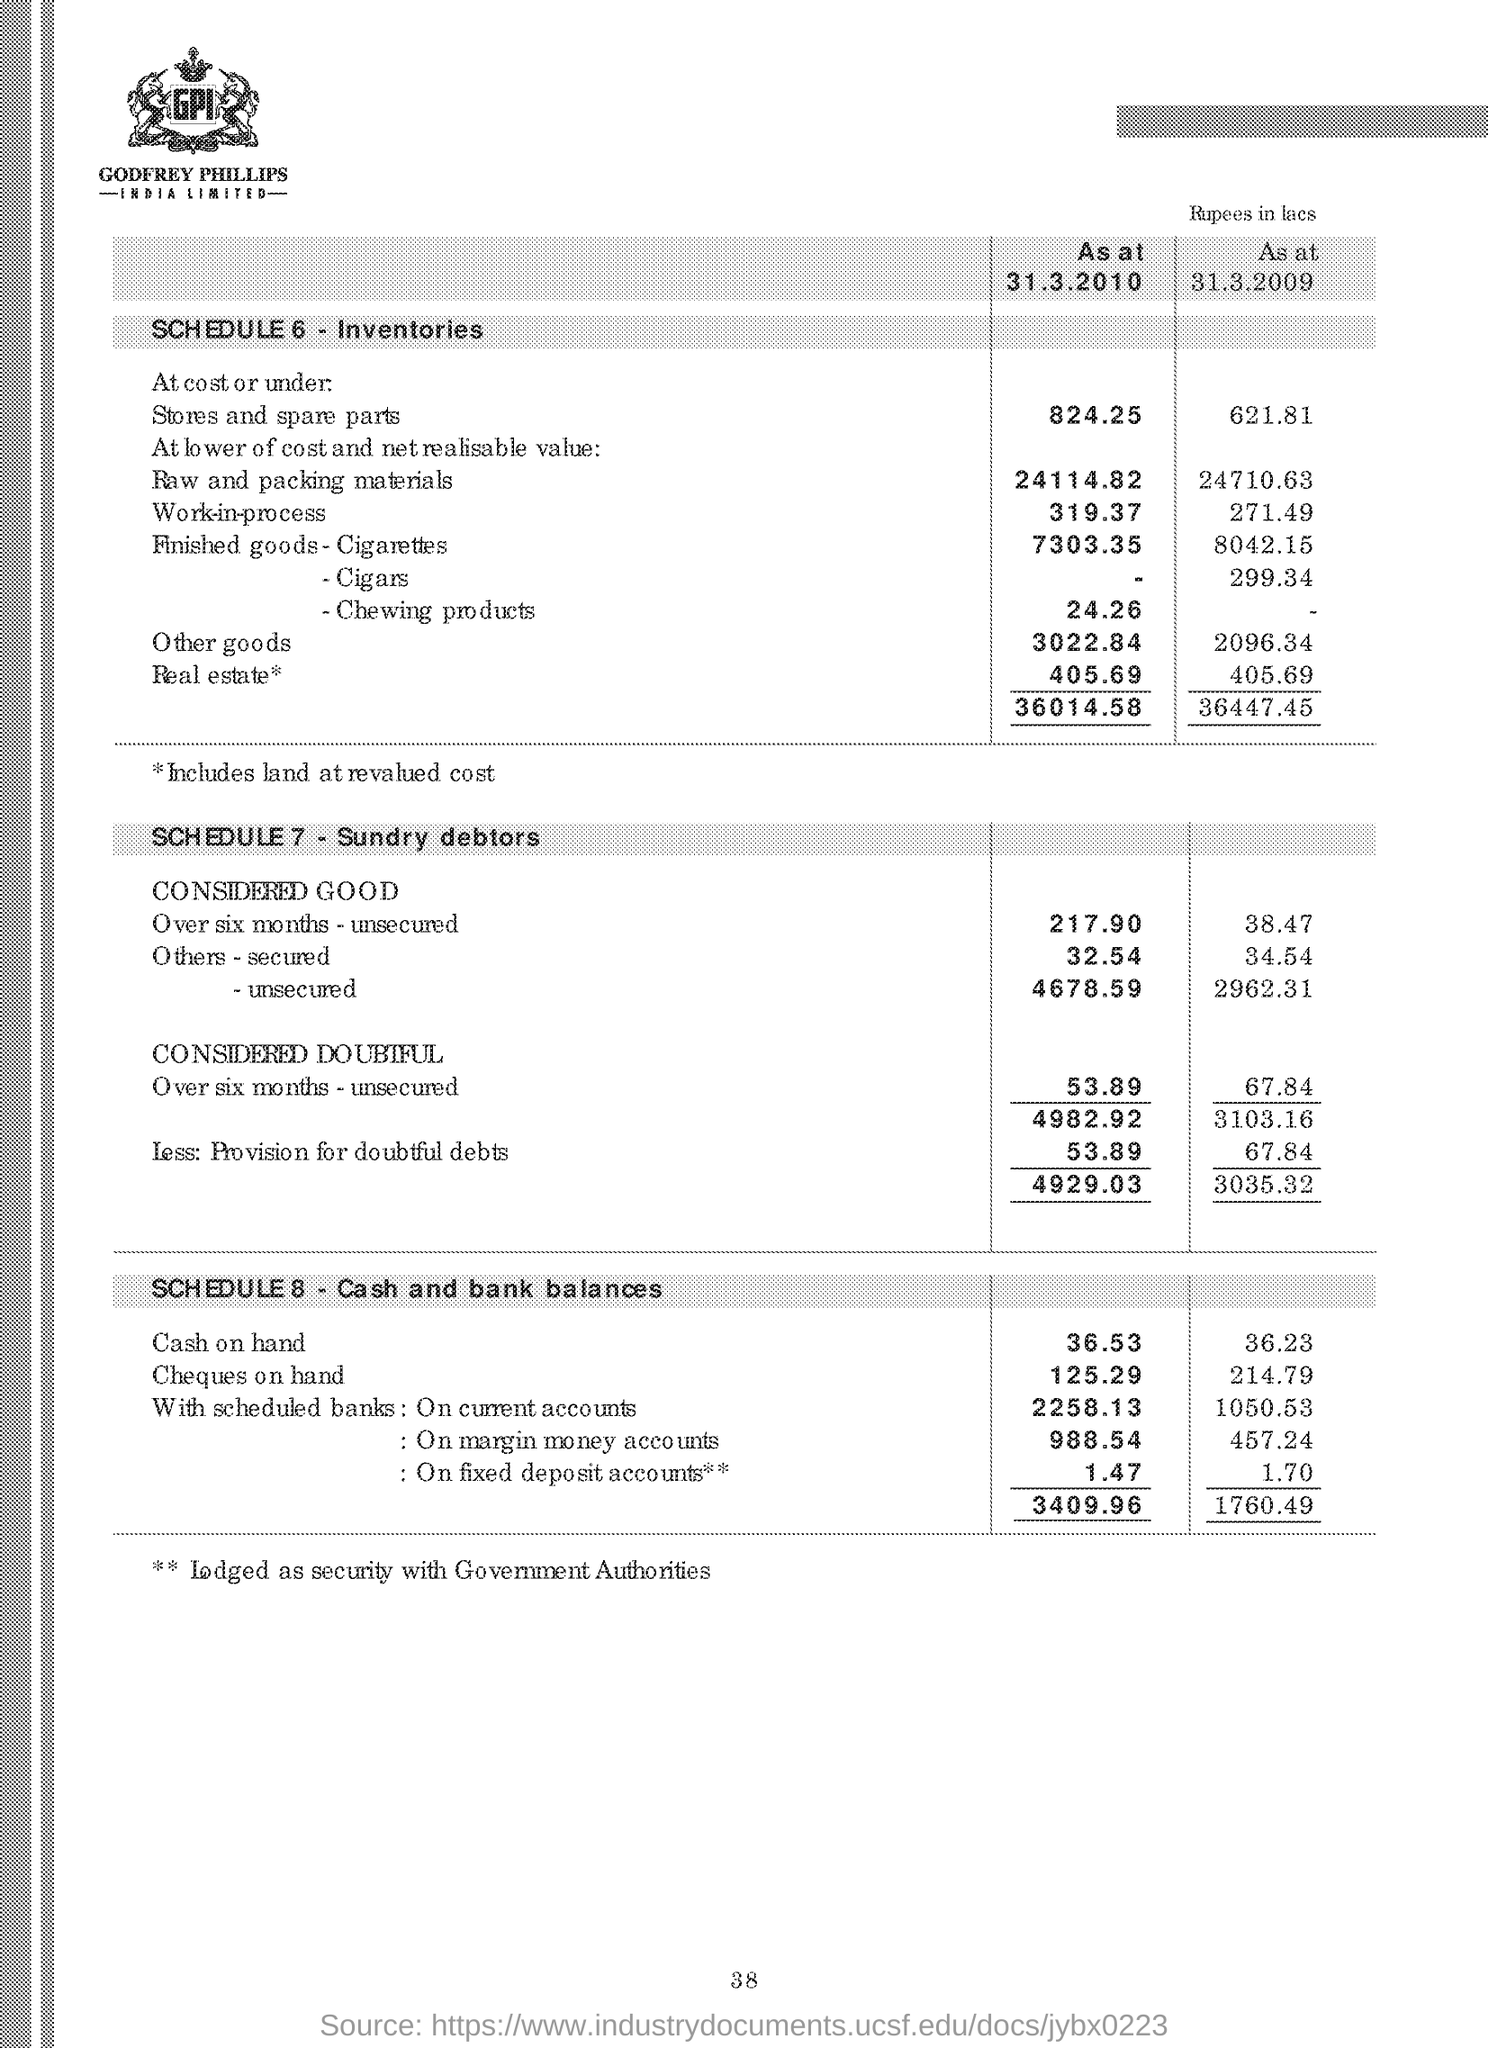Highlight a few significant elements in this photo. The text written in the image is "GODFREY PHILIPS INDIA LIMITED. 